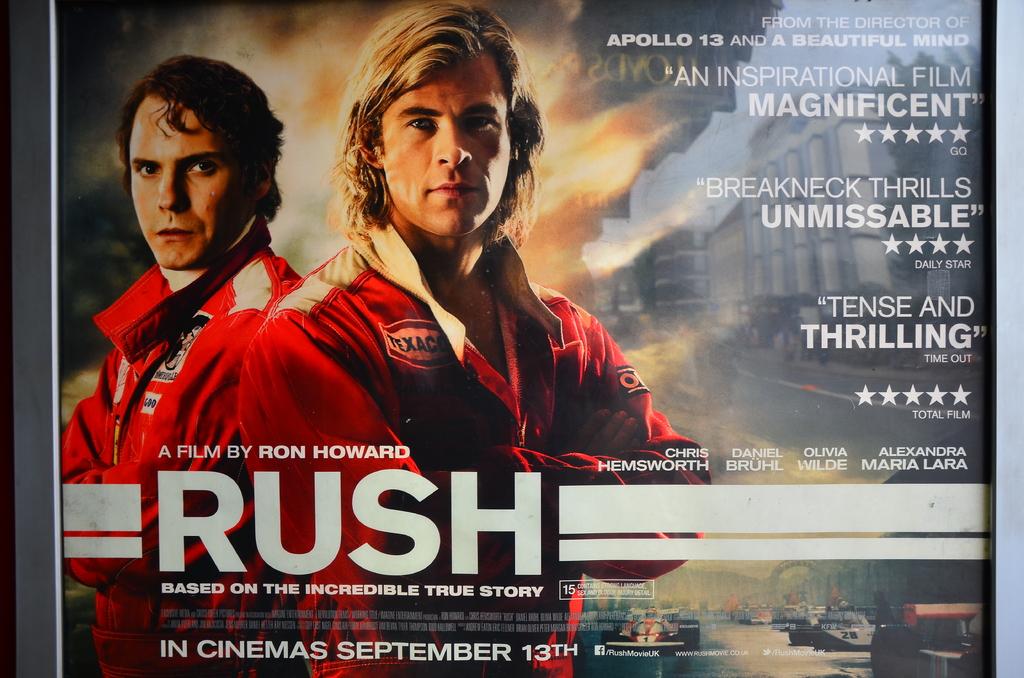What is the album title?
Provide a succinct answer. Rush. Is this listed as thrilling?
Provide a short and direct response. Yes. 